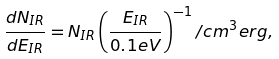Convert formula to latex. <formula><loc_0><loc_0><loc_500><loc_500>\frac { d N _ { I R } } { d E _ { I R } } = N _ { I R } \left ( \frac { E _ { I R } } { 0 . 1 e V } \right ) ^ { - 1 } / c m ^ { 3 } e r g ,</formula> 